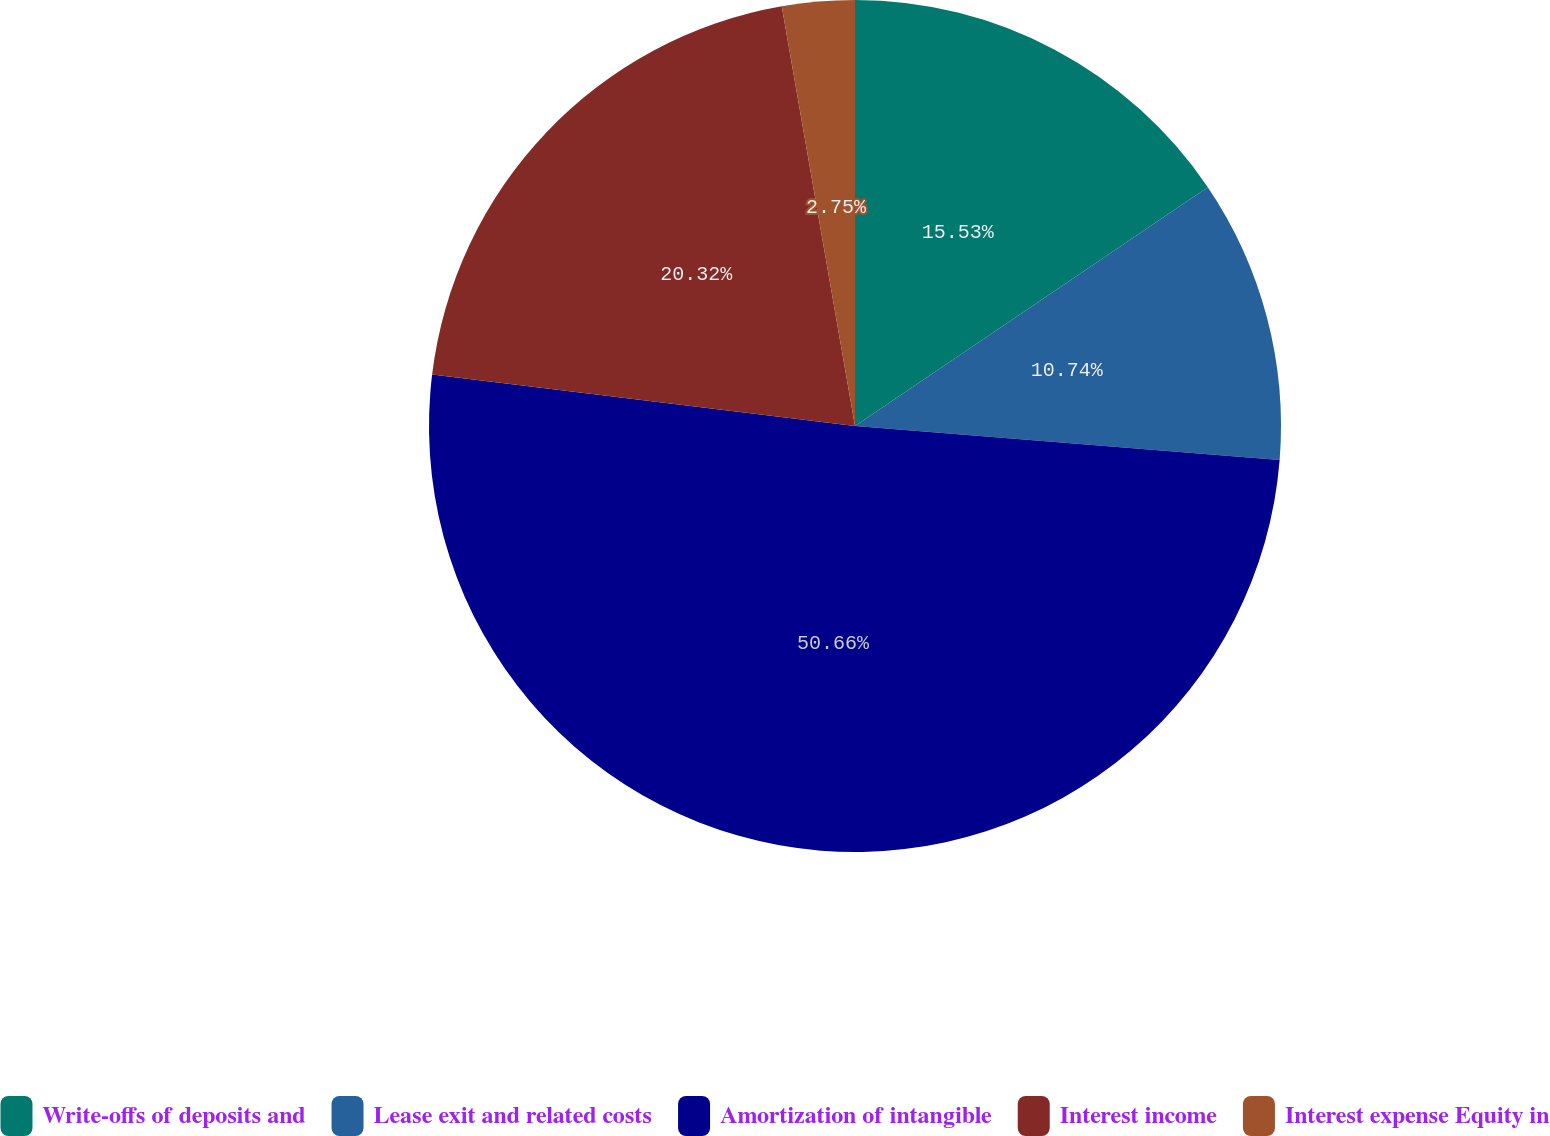<chart> <loc_0><loc_0><loc_500><loc_500><pie_chart><fcel>Write-offs of deposits and<fcel>Lease exit and related costs<fcel>Amortization of intangible<fcel>Interest income<fcel>Interest expense Equity in<nl><fcel>15.53%<fcel>10.74%<fcel>50.65%<fcel>20.32%<fcel>2.75%<nl></chart> 